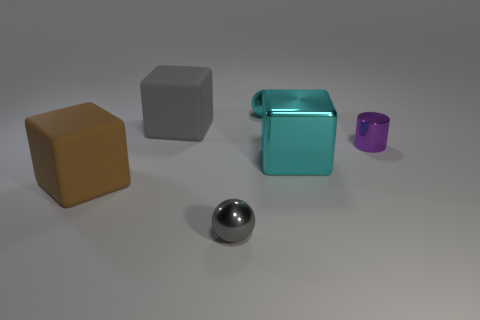Subtract all big cyan metal blocks. How many blocks are left? 2 Subtract all gray blocks. How many blocks are left? 2 Add 3 blue matte things. How many objects exist? 9 Subtract all gray blocks. Subtract all cyan balls. How many blocks are left? 2 Subtract all gray cubes. How many gray balls are left? 1 Subtract all brown rubber blocks. Subtract all small purple shiny cylinders. How many objects are left? 4 Add 6 tiny cyan balls. How many tiny cyan balls are left? 7 Add 1 tiny gray shiny objects. How many tiny gray shiny objects exist? 2 Subtract 1 cyan blocks. How many objects are left? 5 Subtract all cylinders. How many objects are left? 5 